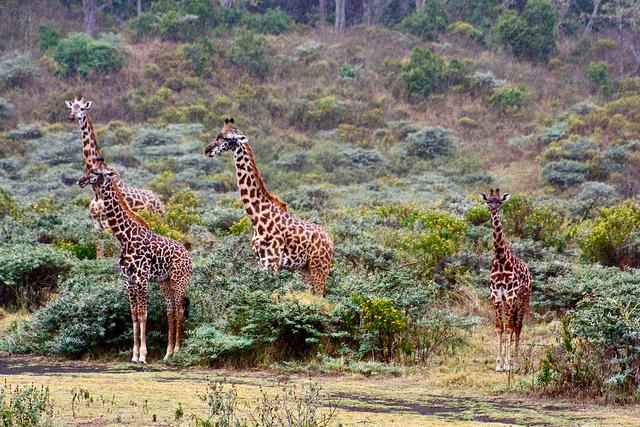Are these animals in a zoo?
Be succinct. No. How many giraffes?
Short answer required. 4. What are the giraffes doing?
Concise answer only. Standing. Where is the wood?
Short answer required. In background. Which giraffe is closest?
Be succinct. Left. Where are the giraffes?
Short answer required. Forest. 